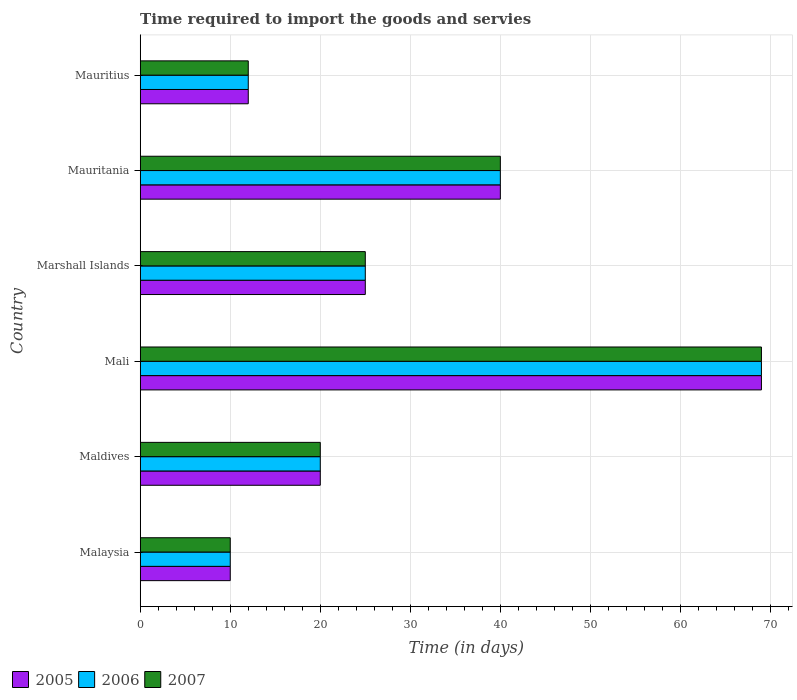How many groups of bars are there?
Your answer should be compact. 6. How many bars are there on the 5th tick from the bottom?
Keep it short and to the point. 3. What is the label of the 4th group of bars from the top?
Your response must be concise. Mali. Across all countries, what is the maximum number of days required to import the goods and services in 2007?
Keep it short and to the point. 69. In which country was the number of days required to import the goods and services in 2005 maximum?
Provide a short and direct response. Mali. In which country was the number of days required to import the goods and services in 2007 minimum?
Your response must be concise. Malaysia. What is the total number of days required to import the goods and services in 2007 in the graph?
Offer a terse response. 176. What is the difference between the number of days required to import the goods and services in 2007 in Marshall Islands and that in Mauritania?
Ensure brevity in your answer.  -15. What is the average number of days required to import the goods and services in 2005 per country?
Give a very brief answer. 29.33. What is the difference between the number of days required to import the goods and services in 2005 and number of days required to import the goods and services in 2006 in Malaysia?
Ensure brevity in your answer.  0. What is the ratio of the number of days required to import the goods and services in 2007 in Malaysia to that in Mauritius?
Keep it short and to the point. 0.83. Is the number of days required to import the goods and services in 2005 in Malaysia less than that in Mauritius?
Ensure brevity in your answer.  Yes. In how many countries, is the number of days required to import the goods and services in 2007 greater than the average number of days required to import the goods and services in 2007 taken over all countries?
Your answer should be compact. 2. What does the 3rd bar from the bottom in Maldives represents?
Offer a terse response. 2007. What is the difference between two consecutive major ticks on the X-axis?
Your answer should be compact. 10. Are the values on the major ticks of X-axis written in scientific E-notation?
Your answer should be very brief. No. Does the graph contain any zero values?
Your answer should be compact. No. How many legend labels are there?
Your answer should be very brief. 3. What is the title of the graph?
Give a very brief answer. Time required to import the goods and servies. Does "2005" appear as one of the legend labels in the graph?
Your response must be concise. Yes. What is the label or title of the X-axis?
Give a very brief answer. Time (in days). What is the Time (in days) in 2005 in Malaysia?
Ensure brevity in your answer.  10. What is the Time (in days) of 2005 in Maldives?
Provide a succinct answer. 20. What is the Time (in days) in 2006 in Mali?
Provide a succinct answer. 69. What is the Time (in days) of 2005 in Marshall Islands?
Your answer should be very brief. 25. What is the Time (in days) of 2007 in Marshall Islands?
Offer a very short reply. 25. What is the Time (in days) of 2005 in Mauritania?
Ensure brevity in your answer.  40. What is the Time (in days) of 2005 in Mauritius?
Your response must be concise. 12. Across all countries, what is the maximum Time (in days) in 2005?
Make the answer very short. 69. Across all countries, what is the maximum Time (in days) in 2006?
Provide a succinct answer. 69. Across all countries, what is the minimum Time (in days) of 2005?
Offer a terse response. 10. Across all countries, what is the minimum Time (in days) of 2006?
Offer a terse response. 10. What is the total Time (in days) of 2005 in the graph?
Your answer should be very brief. 176. What is the total Time (in days) in 2006 in the graph?
Provide a short and direct response. 176. What is the total Time (in days) in 2007 in the graph?
Provide a succinct answer. 176. What is the difference between the Time (in days) in 2005 in Malaysia and that in Maldives?
Your response must be concise. -10. What is the difference between the Time (in days) of 2006 in Malaysia and that in Maldives?
Provide a succinct answer. -10. What is the difference between the Time (in days) of 2005 in Malaysia and that in Mali?
Keep it short and to the point. -59. What is the difference between the Time (in days) in 2006 in Malaysia and that in Mali?
Give a very brief answer. -59. What is the difference between the Time (in days) of 2007 in Malaysia and that in Mali?
Your answer should be compact. -59. What is the difference between the Time (in days) in 2005 in Malaysia and that in Marshall Islands?
Your answer should be very brief. -15. What is the difference between the Time (in days) of 2006 in Malaysia and that in Marshall Islands?
Ensure brevity in your answer.  -15. What is the difference between the Time (in days) in 2007 in Malaysia and that in Marshall Islands?
Give a very brief answer. -15. What is the difference between the Time (in days) in 2006 in Malaysia and that in Mauritania?
Keep it short and to the point. -30. What is the difference between the Time (in days) in 2007 in Malaysia and that in Mauritania?
Keep it short and to the point. -30. What is the difference between the Time (in days) of 2005 in Malaysia and that in Mauritius?
Provide a succinct answer. -2. What is the difference between the Time (in days) in 2006 in Malaysia and that in Mauritius?
Provide a succinct answer. -2. What is the difference between the Time (in days) of 2005 in Maldives and that in Mali?
Your answer should be compact. -49. What is the difference between the Time (in days) of 2006 in Maldives and that in Mali?
Make the answer very short. -49. What is the difference between the Time (in days) in 2007 in Maldives and that in Mali?
Your answer should be compact. -49. What is the difference between the Time (in days) of 2006 in Maldives and that in Marshall Islands?
Provide a short and direct response. -5. What is the difference between the Time (in days) of 2007 in Maldives and that in Marshall Islands?
Make the answer very short. -5. What is the difference between the Time (in days) in 2005 in Maldives and that in Mauritania?
Your response must be concise. -20. What is the difference between the Time (in days) in 2006 in Maldives and that in Mauritania?
Provide a short and direct response. -20. What is the difference between the Time (in days) in 2007 in Maldives and that in Mauritania?
Ensure brevity in your answer.  -20. What is the difference between the Time (in days) of 2007 in Maldives and that in Mauritius?
Make the answer very short. 8. What is the difference between the Time (in days) in 2005 in Mali and that in Marshall Islands?
Make the answer very short. 44. What is the difference between the Time (in days) in 2006 in Mali and that in Marshall Islands?
Keep it short and to the point. 44. What is the difference between the Time (in days) of 2007 in Mali and that in Marshall Islands?
Keep it short and to the point. 44. What is the difference between the Time (in days) in 2005 in Mali and that in Mauritania?
Keep it short and to the point. 29. What is the difference between the Time (in days) in 2006 in Mali and that in Mauritania?
Ensure brevity in your answer.  29. What is the difference between the Time (in days) in 2005 in Mali and that in Mauritius?
Your answer should be very brief. 57. What is the difference between the Time (in days) of 2005 in Marshall Islands and that in Mauritania?
Your response must be concise. -15. What is the difference between the Time (in days) of 2006 in Marshall Islands and that in Mauritania?
Keep it short and to the point. -15. What is the difference between the Time (in days) of 2006 in Marshall Islands and that in Mauritius?
Provide a succinct answer. 13. What is the difference between the Time (in days) of 2006 in Mauritania and that in Mauritius?
Ensure brevity in your answer.  28. What is the difference between the Time (in days) of 2005 in Malaysia and the Time (in days) of 2007 in Maldives?
Ensure brevity in your answer.  -10. What is the difference between the Time (in days) in 2006 in Malaysia and the Time (in days) in 2007 in Maldives?
Ensure brevity in your answer.  -10. What is the difference between the Time (in days) in 2005 in Malaysia and the Time (in days) in 2006 in Mali?
Provide a succinct answer. -59. What is the difference between the Time (in days) of 2005 in Malaysia and the Time (in days) of 2007 in Mali?
Your response must be concise. -59. What is the difference between the Time (in days) in 2006 in Malaysia and the Time (in days) in 2007 in Mali?
Ensure brevity in your answer.  -59. What is the difference between the Time (in days) in 2006 in Malaysia and the Time (in days) in 2007 in Marshall Islands?
Provide a succinct answer. -15. What is the difference between the Time (in days) in 2005 in Malaysia and the Time (in days) in 2007 in Mauritania?
Offer a very short reply. -30. What is the difference between the Time (in days) of 2005 in Malaysia and the Time (in days) of 2006 in Mauritius?
Keep it short and to the point. -2. What is the difference between the Time (in days) in 2006 in Malaysia and the Time (in days) in 2007 in Mauritius?
Make the answer very short. -2. What is the difference between the Time (in days) of 2005 in Maldives and the Time (in days) of 2006 in Mali?
Offer a terse response. -49. What is the difference between the Time (in days) in 2005 in Maldives and the Time (in days) in 2007 in Mali?
Your answer should be compact. -49. What is the difference between the Time (in days) in 2006 in Maldives and the Time (in days) in 2007 in Mali?
Offer a very short reply. -49. What is the difference between the Time (in days) in 2005 in Maldives and the Time (in days) in 2006 in Marshall Islands?
Offer a very short reply. -5. What is the difference between the Time (in days) of 2006 in Maldives and the Time (in days) of 2007 in Marshall Islands?
Your answer should be very brief. -5. What is the difference between the Time (in days) of 2005 in Maldives and the Time (in days) of 2007 in Mauritania?
Your answer should be very brief. -20. What is the difference between the Time (in days) in 2006 in Maldives and the Time (in days) in 2007 in Mauritania?
Offer a very short reply. -20. What is the difference between the Time (in days) of 2005 in Maldives and the Time (in days) of 2007 in Mauritius?
Your response must be concise. 8. What is the difference between the Time (in days) of 2005 in Mali and the Time (in days) of 2007 in Marshall Islands?
Offer a very short reply. 44. What is the difference between the Time (in days) in 2005 in Mali and the Time (in days) in 2006 in Mauritania?
Ensure brevity in your answer.  29. What is the difference between the Time (in days) in 2005 in Mali and the Time (in days) in 2007 in Mauritania?
Provide a short and direct response. 29. What is the difference between the Time (in days) in 2006 in Mali and the Time (in days) in 2007 in Mauritania?
Your response must be concise. 29. What is the difference between the Time (in days) of 2006 in Mali and the Time (in days) of 2007 in Mauritius?
Your answer should be very brief. 57. What is the difference between the Time (in days) of 2005 in Marshall Islands and the Time (in days) of 2007 in Mauritius?
Ensure brevity in your answer.  13. What is the difference between the Time (in days) of 2006 in Marshall Islands and the Time (in days) of 2007 in Mauritius?
Give a very brief answer. 13. What is the difference between the Time (in days) of 2005 in Mauritania and the Time (in days) of 2007 in Mauritius?
Make the answer very short. 28. What is the difference between the Time (in days) of 2006 in Mauritania and the Time (in days) of 2007 in Mauritius?
Provide a short and direct response. 28. What is the average Time (in days) in 2005 per country?
Offer a terse response. 29.33. What is the average Time (in days) in 2006 per country?
Your answer should be very brief. 29.33. What is the average Time (in days) in 2007 per country?
Your response must be concise. 29.33. What is the difference between the Time (in days) of 2005 and Time (in days) of 2006 in Malaysia?
Offer a terse response. 0. What is the difference between the Time (in days) of 2005 and Time (in days) of 2007 in Maldives?
Ensure brevity in your answer.  0. What is the difference between the Time (in days) in 2006 and Time (in days) in 2007 in Maldives?
Your response must be concise. 0. What is the difference between the Time (in days) in 2005 and Time (in days) in 2006 in Mali?
Give a very brief answer. 0. What is the difference between the Time (in days) of 2006 and Time (in days) of 2007 in Mali?
Your answer should be very brief. 0. What is the difference between the Time (in days) in 2005 and Time (in days) in 2006 in Marshall Islands?
Keep it short and to the point. 0. What is the difference between the Time (in days) in 2005 and Time (in days) in 2007 in Mauritania?
Ensure brevity in your answer.  0. What is the difference between the Time (in days) in 2006 and Time (in days) in 2007 in Mauritania?
Make the answer very short. 0. What is the difference between the Time (in days) in 2005 and Time (in days) in 2006 in Mauritius?
Give a very brief answer. 0. What is the ratio of the Time (in days) of 2005 in Malaysia to that in Mali?
Give a very brief answer. 0.14. What is the ratio of the Time (in days) of 2006 in Malaysia to that in Mali?
Your answer should be compact. 0.14. What is the ratio of the Time (in days) in 2007 in Malaysia to that in Mali?
Provide a succinct answer. 0.14. What is the ratio of the Time (in days) of 2005 in Malaysia to that in Marshall Islands?
Offer a very short reply. 0.4. What is the ratio of the Time (in days) of 2005 in Malaysia to that in Mauritania?
Provide a succinct answer. 0.25. What is the ratio of the Time (in days) of 2005 in Malaysia to that in Mauritius?
Your answer should be very brief. 0.83. What is the ratio of the Time (in days) of 2006 in Malaysia to that in Mauritius?
Your answer should be compact. 0.83. What is the ratio of the Time (in days) in 2005 in Maldives to that in Mali?
Give a very brief answer. 0.29. What is the ratio of the Time (in days) of 2006 in Maldives to that in Mali?
Offer a very short reply. 0.29. What is the ratio of the Time (in days) in 2007 in Maldives to that in Mali?
Provide a succinct answer. 0.29. What is the ratio of the Time (in days) in 2005 in Maldives to that in Marshall Islands?
Your answer should be very brief. 0.8. What is the ratio of the Time (in days) of 2006 in Maldives to that in Mauritania?
Your answer should be very brief. 0.5. What is the ratio of the Time (in days) of 2007 in Maldives to that in Mauritania?
Provide a succinct answer. 0.5. What is the ratio of the Time (in days) of 2007 in Maldives to that in Mauritius?
Offer a terse response. 1.67. What is the ratio of the Time (in days) in 2005 in Mali to that in Marshall Islands?
Keep it short and to the point. 2.76. What is the ratio of the Time (in days) of 2006 in Mali to that in Marshall Islands?
Give a very brief answer. 2.76. What is the ratio of the Time (in days) of 2007 in Mali to that in Marshall Islands?
Provide a short and direct response. 2.76. What is the ratio of the Time (in days) of 2005 in Mali to that in Mauritania?
Offer a terse response. 1.73. What is the ratio of the Time (in days) of 2006 in Mali to that in Mauritania?
Your answer should be compact. 1.73. What is the ratio of the Time (in days) of 2007 in Mali to that in Mauritania?
Offer a terse response. 1.73. What is the ratio of the Time (in days) of 2005 in Mali to that in Mauritius?
Your response must be concise. 5.75. What is the ratio of the Time (in days) in 2006 in Mali to that in Mauritius?
Give a very brief answer. 5.75. What is the ratio of the Time (in days) of 2007 in Mali to that in Mauritius?
Provide a succinct answer. 5.75. What is the ratio of the Time (in days) of 2005 in Marshall Islands to that in Mauritania?
Keep it short and to the point. 0.62. What is the ratio of the Time (in days) of 2006 in Marshall Islands to that in Mauritania?
Your answer should be compact. 0.62. What is the ratio of the Time (in days) in 2005 in Marshall Islands to that in Mauritius?
Your answer should be compact. 2.08. What is the ratio of the Time (in days) of 2006 in Marshall Islands to that in Mauritius?
Provide a short and direct response. 2.08. What is the ratio of the Time (in days) of 2007 in Marshall Islands to that in Mauritius?
Provide a succinct answer. 2.08. What is the ratio of the Time (in days) in 2005 in Mauritania to that in Mauritius?
Keep it short and to the point. 3.33. What is the ratio of the Time (in days) in 2007 in Mauritania to that in Mauritius?
Make the answer very short. 3.33. What is the difference between the highest and the second highest Time (in days) of 2006?
Ensure brevity in your answer.  29. What is the difference between the highest and the lowest Time (in days) of 2006?
Give a very brief answer. 59. What is the difference between the highest and the lowest Time (in days) of 2007?
Give a very brief answer. 59. 